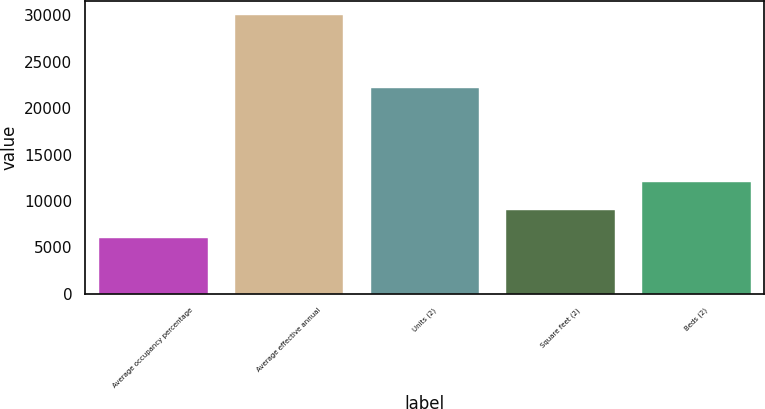Convert chart to OTSL. <chart><loc_0><loc_0><loc_500><loc_500><bar_chart><fcel>Average occupancy percentage<fcel>Average effective annual<fcel>Units (2)<fcel>Square feet (2)<fcel>Beds (2)<nl><fcel>6029.4<fcel>30063<fcel>22142<fcel>9033.6<fcel>12037.8<nl></chart> 